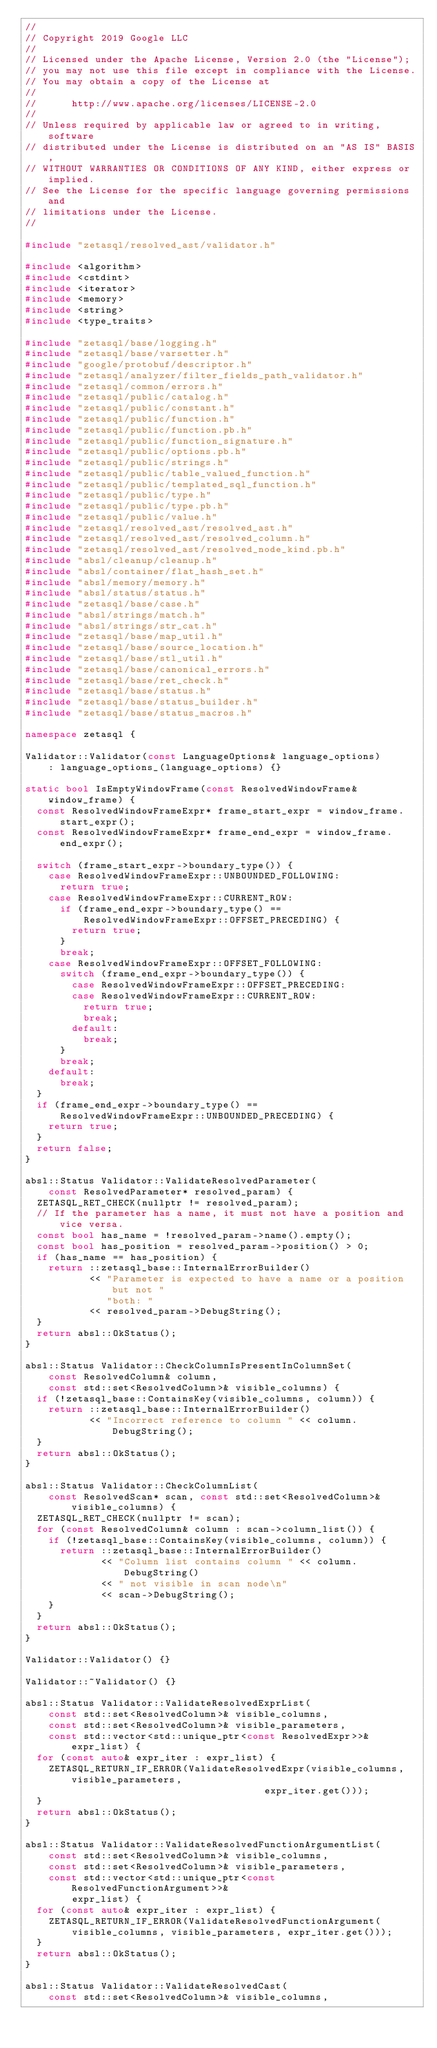<code> <loc_0><loc_0><loc_500><loc_500><_C++_>//
// Copyright 2019 Google LLC
//
// Licensed under the Apache License, Version 2.0 (the "License");
// you may not use this file except in compliance with the License.
// You may obtain a copy of the License at
//
//      http://www.apache.org/licenses/LICENSE-2.0
//
// Unless required by applicable law or agreed to in writing, software
// distributed under the License is distributed on an "AS IS" BASIS,
// WITHOUT WARRANTIES OR CONDITIONS OF ANY KIND, either express or implied.
// See the License for the specific language governing permissions and
// limitations under the License.
//

#include "zetasql/resolved_ast/validator.h"

#include <algorithm>
#include <cstdint>
#include <iterator>
#include <memory>
#include <string>
#include <type_traits>

#include "zetasql/base/logging.h"
#include "zetasql/base/varsetter.h"
#include "google/protobuf/descriptor.h"
#include "zetasql/analyzer/filter_fields_path_validator.h"
#include "zetasql/common/errors.h"
#include "zetasql/public/catalog.h"
#include "zetasql/public/constant.h"
#include "zetasql/public/function.h"
#include "zetasql/public/function.pb.h"
#include "zetasql/public/function_signature.h"
#include "zetasql/public/options.pb.h"
#include "zetasql/public/strings.h"
#include "zetasql/public/table_valued_function.h"
#include "zetasql/public/templated_sql_function.h"
#include "zetasql/public/type.h"
#include "zetasql/public/type.pb.h"
#include "zetasql/public/value.h"
#include "zetasql/resolved_ast/resolved_ast.h"
#include "zetasql/resolved_ast/resolved_column.h"
#include "zetasql/resolved_ast/resolved_node_kind.pb.h"
#include "absl/cleanup/cleanup.h"
#include "absl/container/flat_hash_set.h"
#include "absl/memory/memory.h"
#include "absl/status/status.h"
#include "zetasql/base/case.h"
#include "absl/strings/match.h"
#include "absl/strings/str_cat.h"
#include "zetasql/base/map_util.h"
#include "zetasql/base/source_location.h"
#include "zetasql/base/stl_util.h"
#include "zetasql/base/canonical_errors.h"
#include "zetasql/base/ret_check.h"
#include "zetasql/base/status.h"
#include "zetasql/base/status_builder.h"
#include "zetasql/base/status_macros.h"

namespace zetasql {

Validator::Validator(const LanguageOptions& language_options)
    : language_options_(language_options) {}

static bool IsEmptyWindowFrame(const ResolvedWindowFrame& window_frame) {
  const ResolvedWindowFrameExpr* frame_start_expr = window_frame.start_expr();
  const ResolvedWindowFrameExpr* frame_end_expr = window_frame.end_expr();

  switch (frame_start_expr->boundary_type()) {
    case ResolvedWindowFrameExpr::UNBOUNDED_FOLLOWING:
      return true;
    case ResolvedWindowFrameExpr::CURRENT_ROW:
      if (frame_end_expr->boundary_type() ==
          ResolvedWindowFrameExpr::OFFSET_PRECEDING) {
        return true;
      }
      break;
    case ResolvedWindowFrameExpr::OFFSET_FOLLOWING:
      switch (frame_end_expr->boundary_type()) {
        case ResolvedWindowFrameExpr::OFFSET_PRECEDING:
        case ResolvedWindowFrameExpr::CURRENT_ROW:
          return true;
          break;
        default:
          break;
      }
      break;
    default:
      break;
  }
  if (frame_end_expr->boundary_type() ==
      ResolvedWindowFrameExpr::UNBOUNDED_PRECEDING) {
    return true;
  }
  return false;
}

absl::Status Validator::ValidateResolvedParameter(
    const ResolvedParameter* resolved_param) {
  ZETASQL_RET_CHECK(nullptr != resolved_param);
  // If the parameter has a name, it must not have a position and vice versa.
  const bool has_name = !resolved_param->name().empty();
  const bool has_position = resolved_param->position() > 0;
  if (has_name == has_position) {
    return ::zetasql_base::InternalErrorBuilder()
           << "Parameter is expected to have a name or a position but not "
              "both: "
           << resolved_param->DebugString();
  }
  return absl::OkStatus();
}

absl::Status Validator::CheckColumnIsPresentInColumnSet(
    const ResolvedColumn& column,
    const std::set<ResolvedColumn>& visible_columns) {
  if (!zetasql_base::ContainsKey(visible_columns, column)) {
    return ::zetasql_base::InternalErrorBuilder()
           << "Incorrect reference to column " << column.DebugString();
  }
  return absl::OkStatus();
}

absl::Status Validator::CheckColumnList(
    const ResolvedScan* scan, const std::set<ResolvedColumn>& visible_columns) {
  ZETASQL_RET_CHECK(nullptr != scan);
  for (const ResolvedColumn& column : scan->column_list()) {
    if (!zetasql_base::ContainsKey(visible_columns, column)) {
      return ::zetasql_base::InternalErrorBuilder()
             << "Column list contains column " << column.DebugString()
             << " not visible in scan node\n"
             << scan->DebugString();
    }
  }
  return absl::OkStatus();
}

Validator::Validator() {}

Validator::~Validator() {}

absl::Status Validator::ValidateResolvedExprList(
    const std::set<ResolvedColumn>& visible_columns,
    const std::set<ResolvedColumn>& visible_parameters,
    const std::vector<std::unique_ptr<const ResolvedExpr>>& expr_list) {
  for (const auto& expr_iter : expr_list) {
    ZETASQL_RETURN_IF_ERROR(ValidateResolvedExpr(visible_columns, visible_parameters,
                                         expr_iter.get()));
  }
  return absl::OkStatus();
}

absl::Status Validator::ValidateResolvedFunctionArgumentList(
    const std::set<ResolvedColumn>& visible_columns,
    const std::set<ResolvedColumn>& visible_parameters,
    const std::vector<std::unique_ptr<const ResolvedFunctionArgument>>&
        expr_list) {
  for (const auto& expr_iter : expr_list) {
    ZETASQL_RETURN_IF_ERROR(ValidateResolvedFunctionArgument(
        visible_columns, visible_parameters, expr_iter.get()));
  }
  return absl::OkStatus();
}

absl::Status Validator::ValidateResolvedCast(
    const std::set<ResolvedColumn>& visible_columns,</code> 